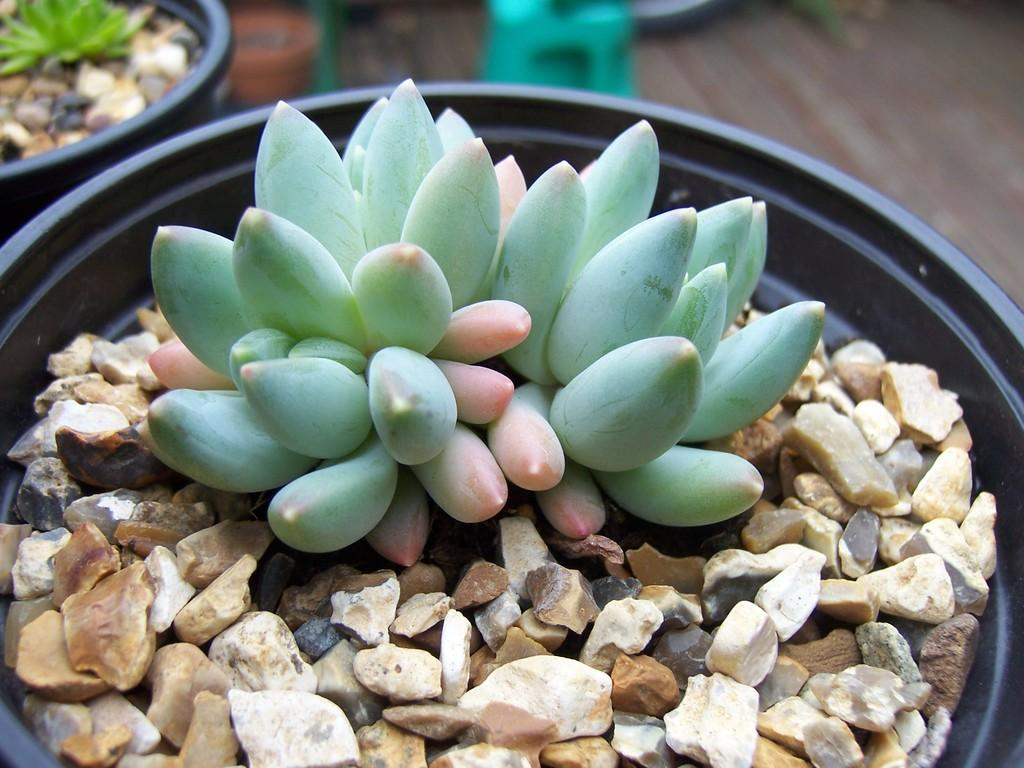What objects are present in the image related to plants? There are plant pots in the image. What is inside the plant pots? The plant pots contain stones. Can you describe the background of the image? The background of the image is blurred. How many caps can be seen on the stones in the image? There are no caps present in the image; the plant pots contain stones without any caps. 